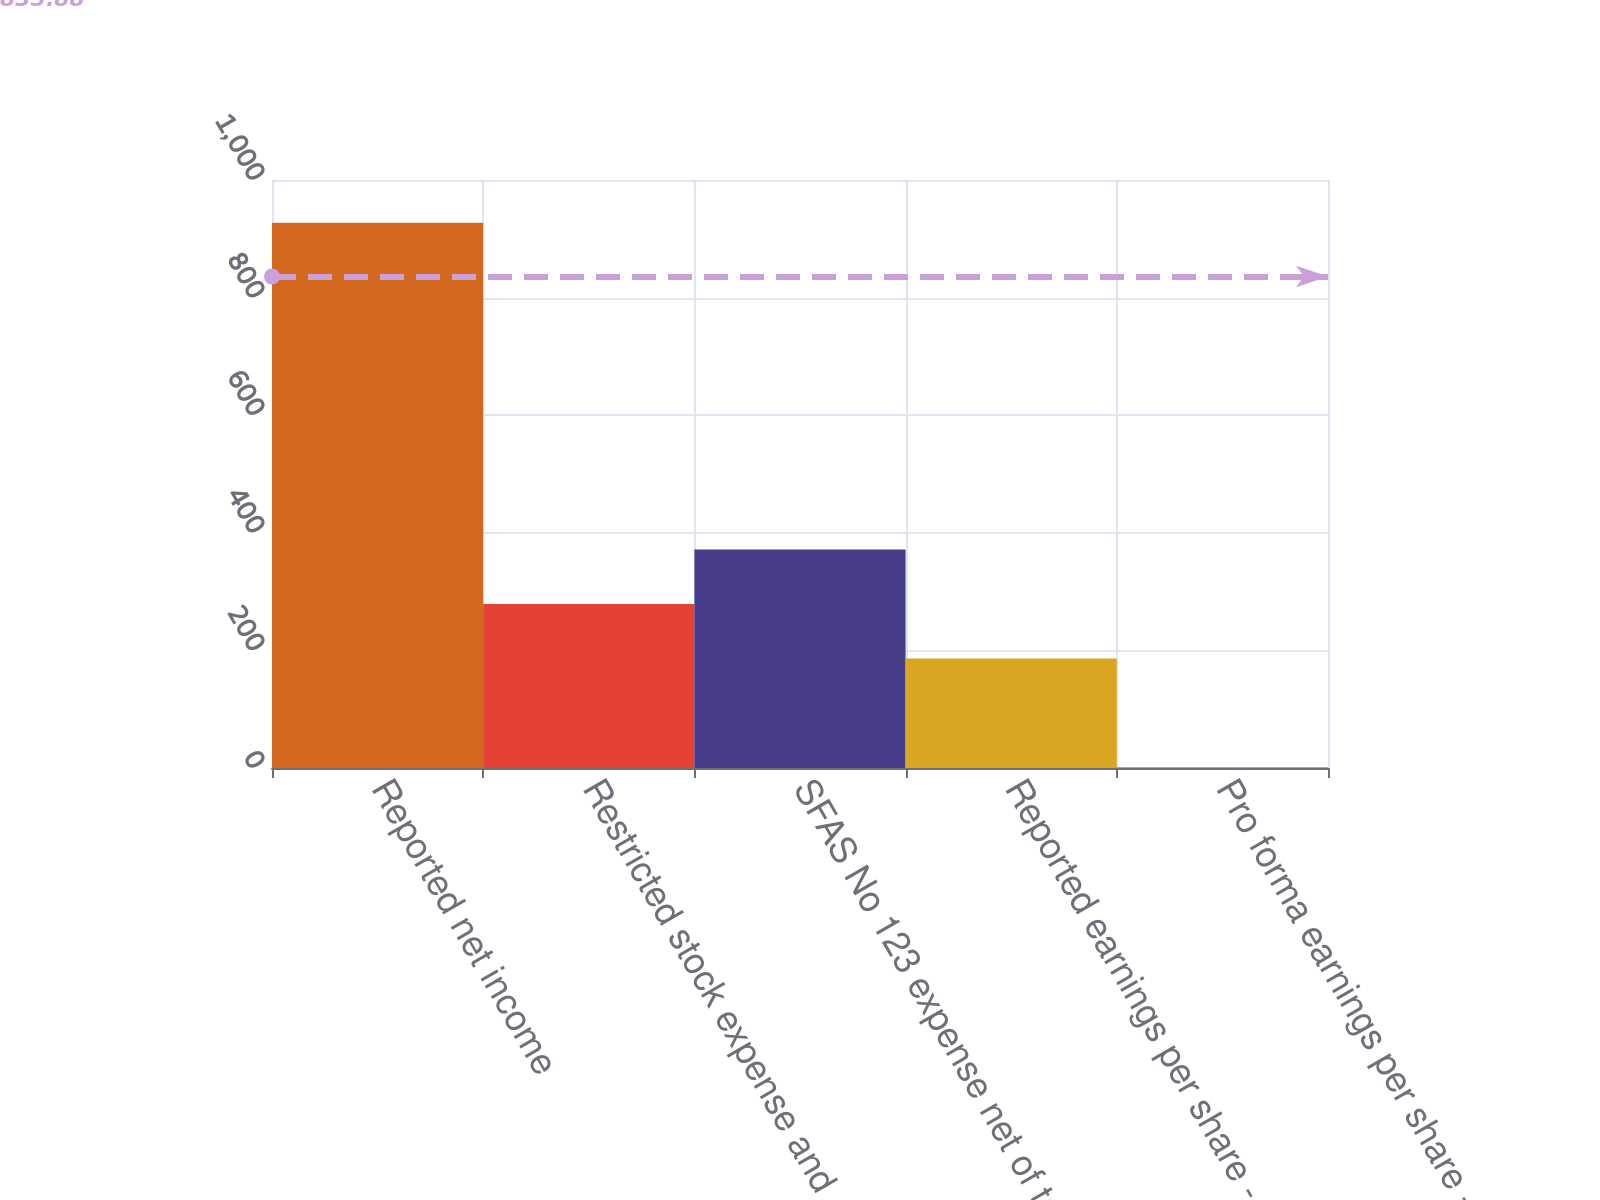Convert chart to OTSL. <chart><loc_0><loc_0><loc_500><loc_500><bar_chart><fcel>Reported net income<fcel>Restricted stock expense and<fcel>SFAS No 123 expense net of tax<fcel>Reported earnings per share -<fcel>Pro forma earnings per share -<nl><fcel>927.4<fcel>279.03<fcel>371.65<fcel>186.41<fcel>1.17<nl></chart> 